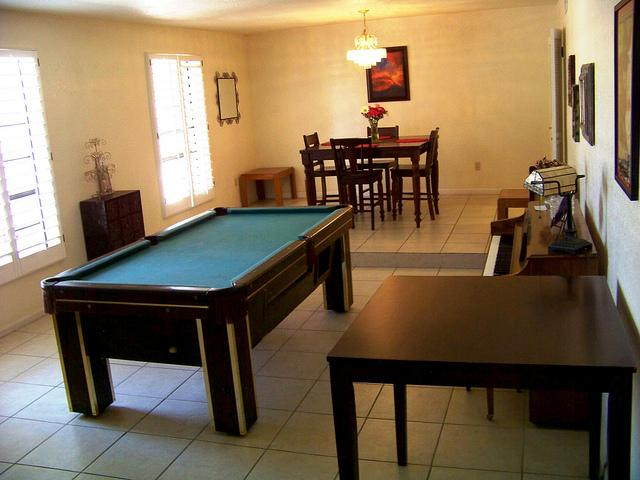What kind of room is this one? recreation room 